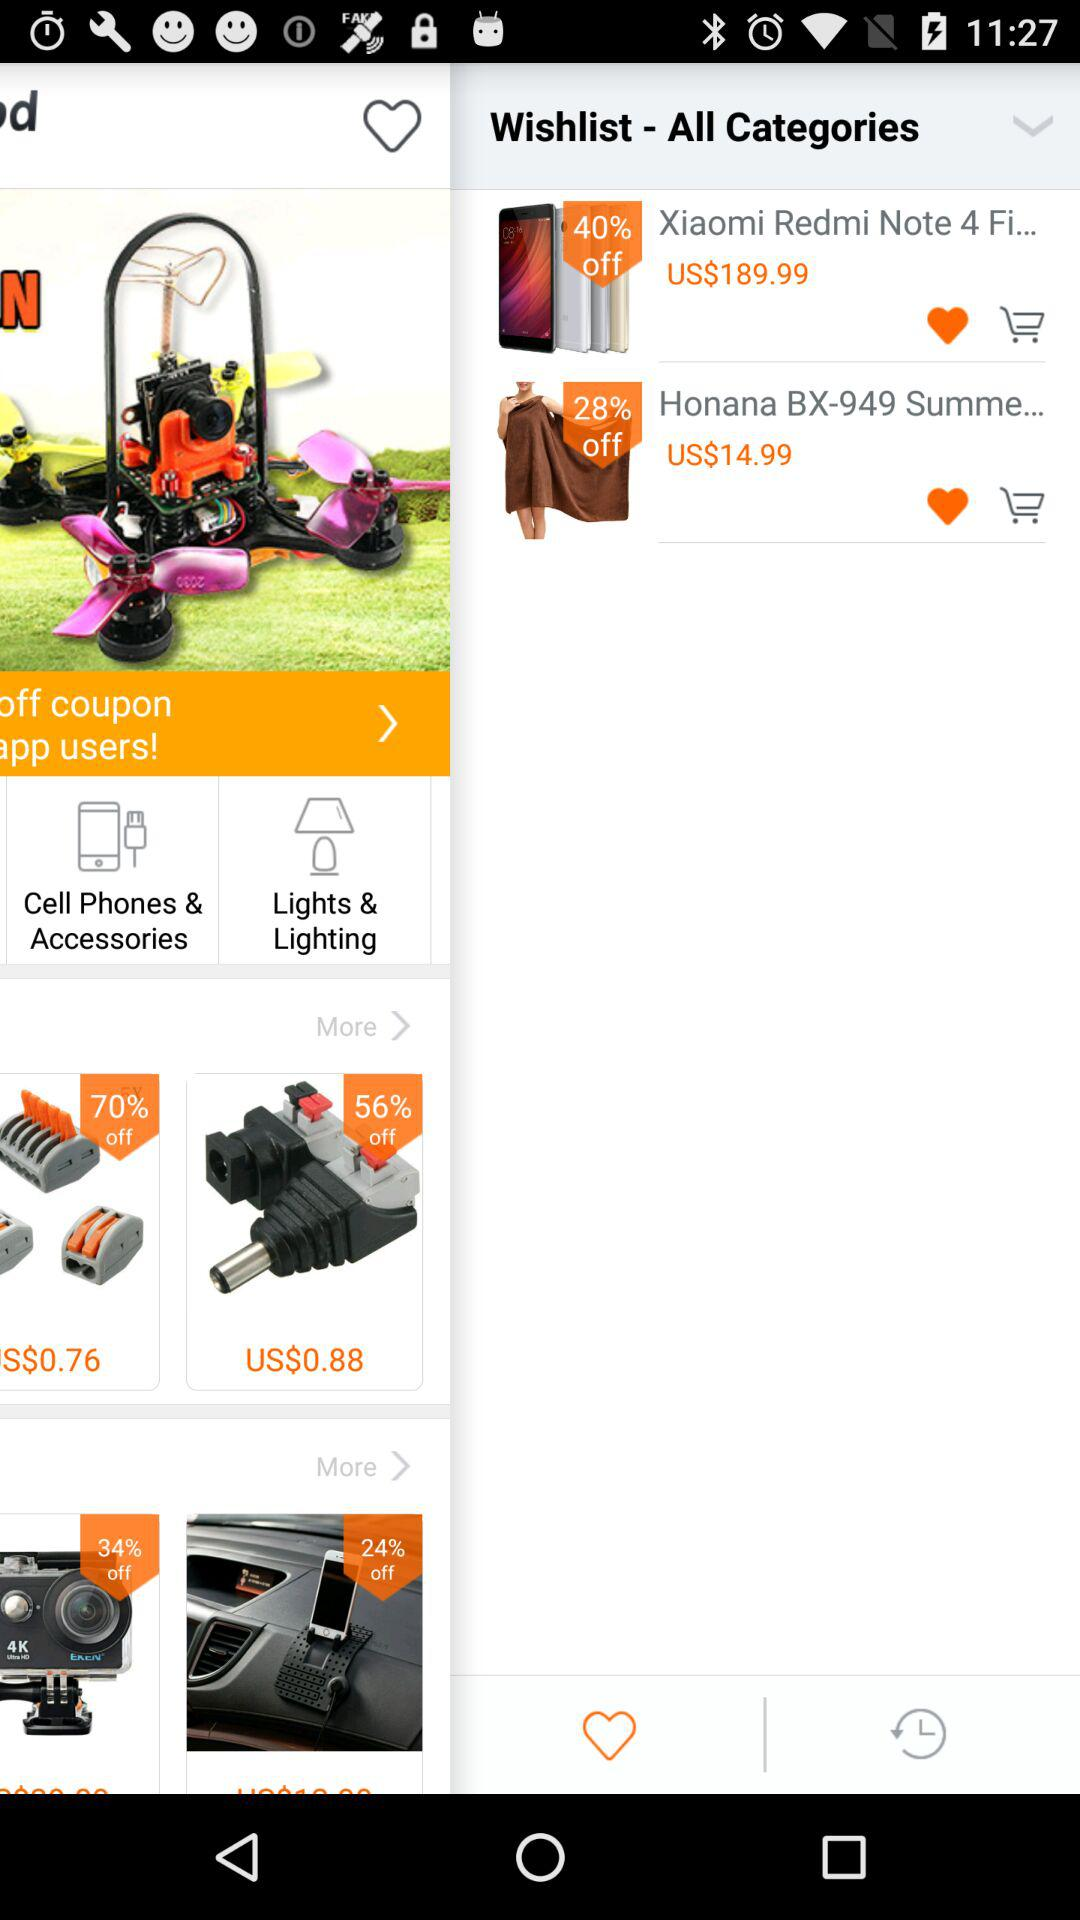What is the currency of price? The currency of price is the US dollar. 